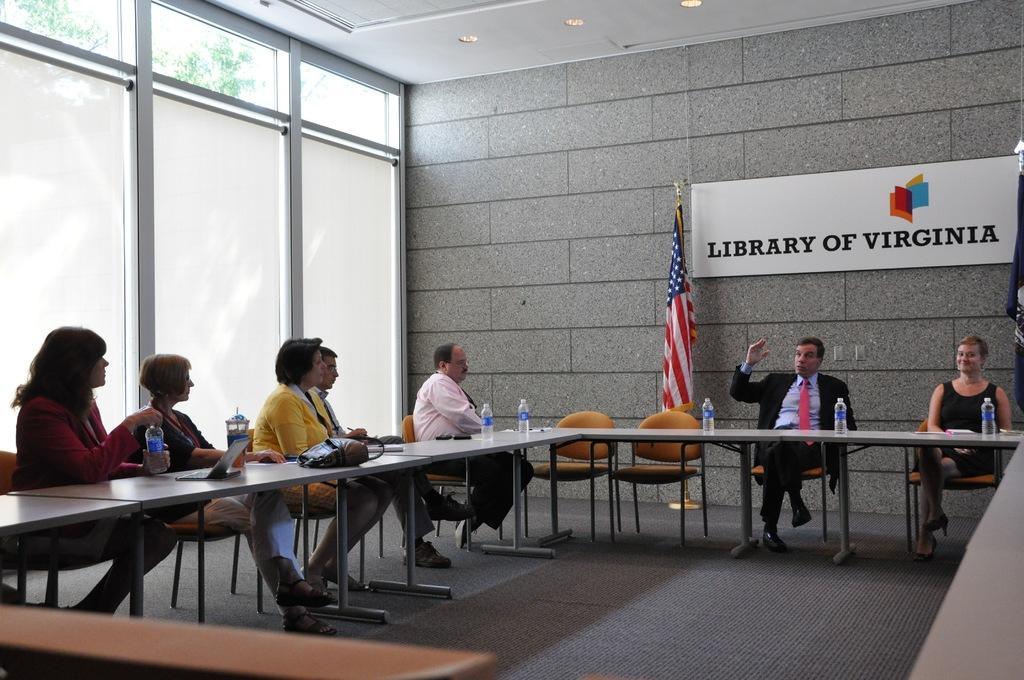Please provide a concise description of this image. The picture consists of people where there are sitting on the chairs and in front of them there is a table on which water bottles, laptops, papers are present and behind them there is a flag and a wall and on the wall their is one board kept with some text written on it and there is one big window where outside the window there are trees. 